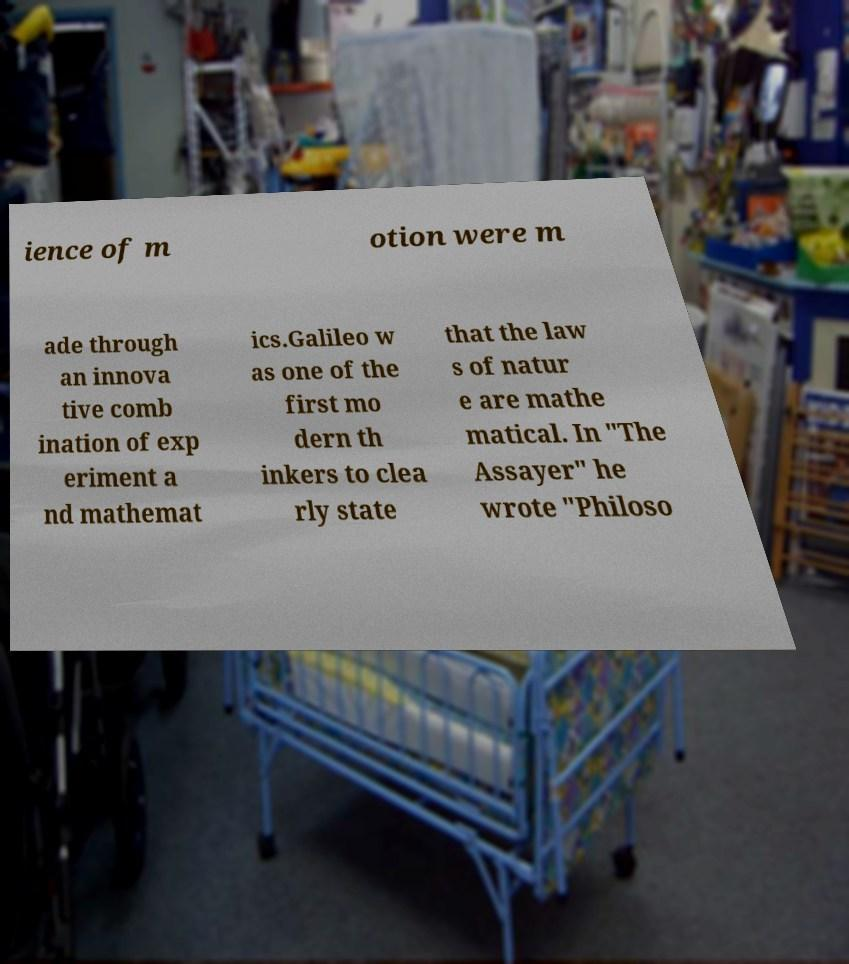Please read and relay the text visible in this image. What does it say? ience of m otion were m ade through an innova tive comb ination of exp eriment a nd mathemat ics.Galileo w as one of the first mo dern th inkers to clea rly state that the law s of natur e are mathe matical. In "The Assayer" he wrote "Philoso 